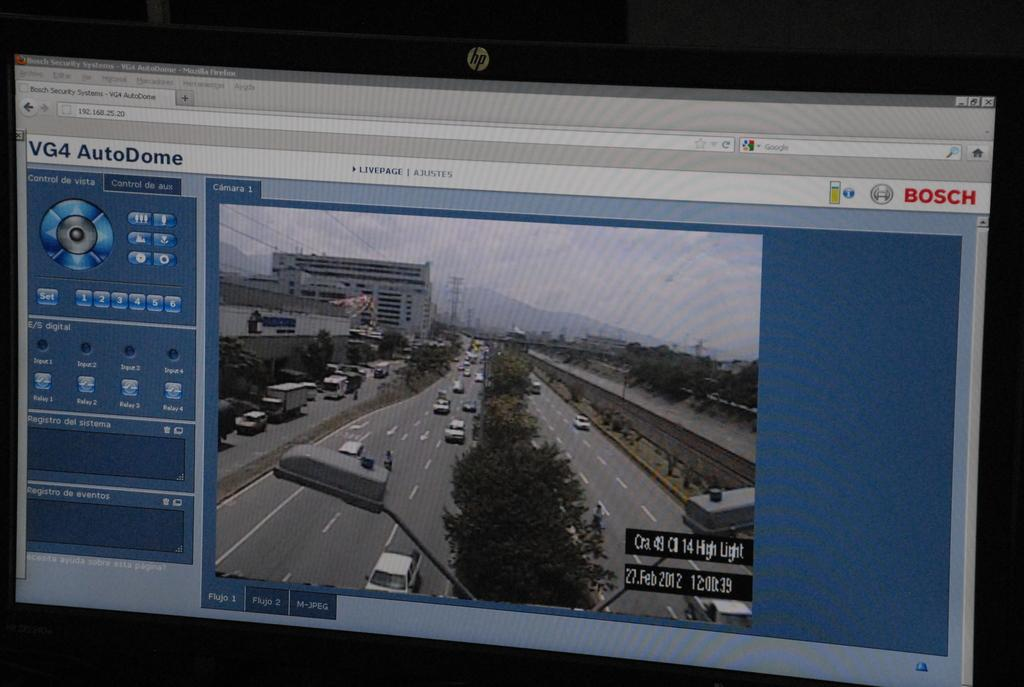Provide a one-sentence caption for the provided image. The footage shown of the road was taken on 27 Feb 2012. 